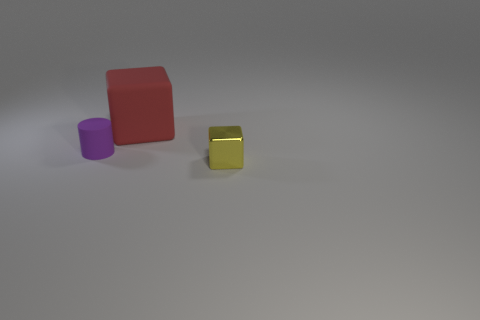Add 1 tiny metal cubes. How many objects exist? 4 Subtract all cubes. How many objects are left? 1 Add 1 small yellow shiny blocks. How many small yellow shiny blocks are left? 2 Add 1 metal objects. How many metal objects exist? 2 Subtract 1 purple cylinders. How many objects are left? 2 Subtract all blue spheres. Subtract all red rubber blocks. How many objects are left? 2 